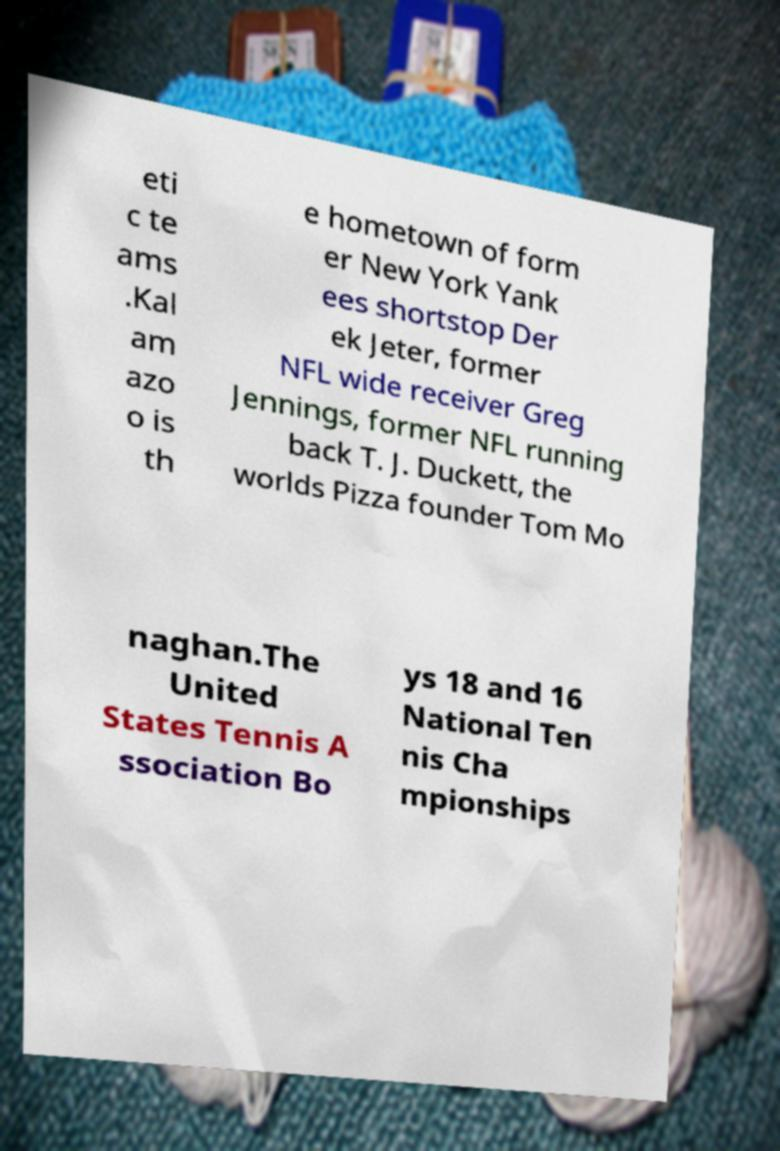Could you assist in decoding the text presented in this image and type it out clearly? eti c te ams .Kal am azo o is th e hometown of form er New York Yank ees shortstop Der ek Jeter, former NFL wide receiver Greg Jennings, former NFL running back T. J. Duckett, the worlds Pizza founder Tom Mo naghan.The United States Tennis A ssociation Bo ys 18 and 16 National Ten nis Cha mpionships 